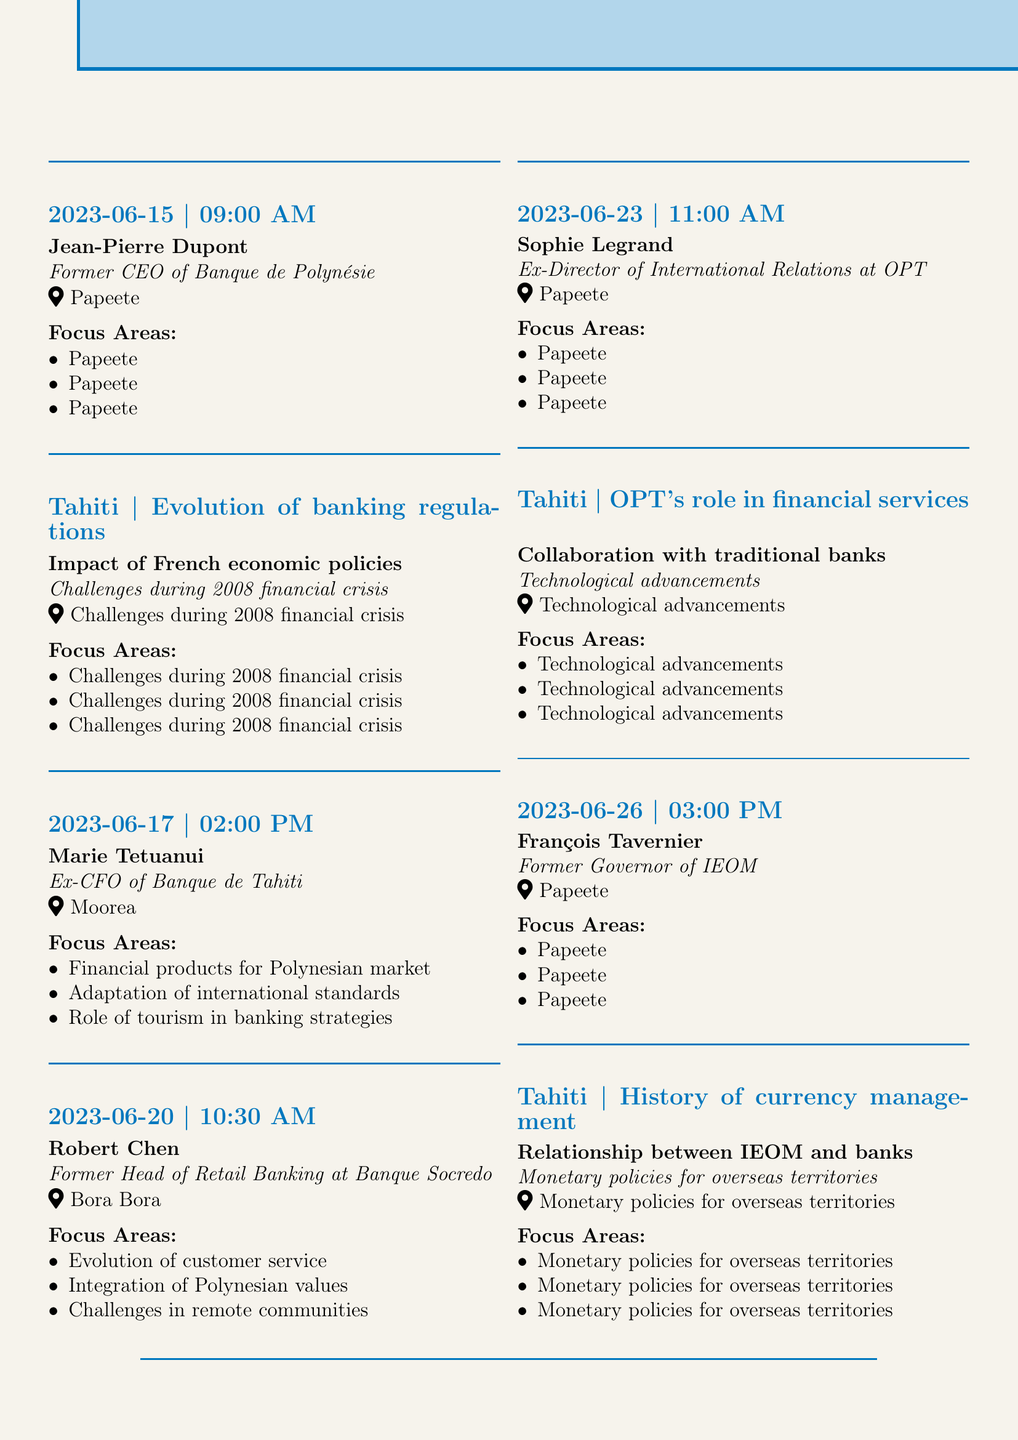What is the date of the interview with Jean-Pierre Dupont? The date of Jean-Pierre Dupont's interview is listed as June 15, 2023.
Answer: June 15, 2023 What is the focus area of Marie Tetuanui's interview? One of the focus areas for Marie Tetuanui's interview is "Financial products tailored for the Polynesian market."
Answer: Financial products tailored for the Polynesian market Who was the former Head of Retail Banking at Banque Socredo? The document identifies Robert Chen as the former Head of Retail Banking at Banque Socredo.
Answer: Robert Chen How many interviews are scheduled in total? There are five interviews scheduled in the document.
Answer: Five Where is François Tavernier's interview located? The document notes that François Tavernier's interview is located in Papeete, Tahiti.
Answer: Papeete, Tahiti What role did Sophie Legrand hold at the Office des Postes et Télécommunications? Sophie Legrand's position at the Office des Postes et Télécommunications was Ex-Director of International Relations.
Answer: Ex-Director of International Relations What is one of the challenges discussed in Robert Chen's interview? One challenge mentioned in Robert Chen's interview is "Challenges of operating in remote island communities."
Answer: Challenges of operating in remote island communities Which institution is mentioned in the document that focuses on historical economic indicators? The Institut de la Statistique de la Polynésie Française (ISPF) focuses on historical economic indicators as mentioned in the document.
Answer: Institut de la Statistique de la Polynésie Française (ISPF) 